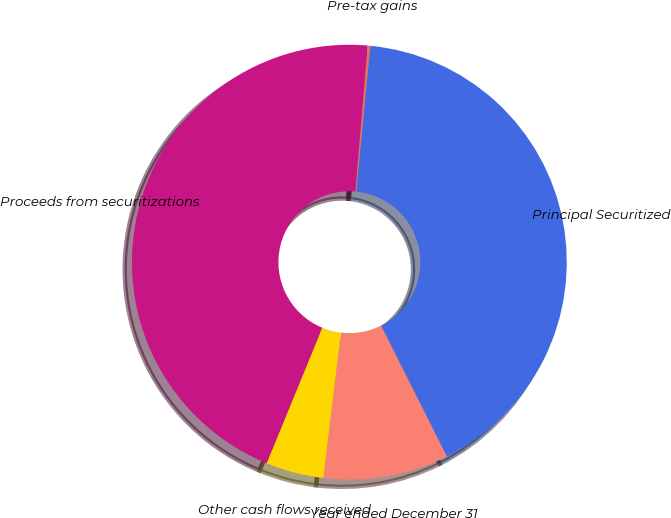Convert chart. <chart><loc_0><loc_0><loc_500><loc_500><pie_chart><fcel>Year ended December 31<fcel>Principal Securitized<fcel>Pre-tax gains<fcel>Proceeds from securitizations<fcel>Other cash flows received<nl><fcel>9.32%<fcel>41.05%<fcel>0.2%<fcel>45.14%<fcel>4.29%<nl></chart> 